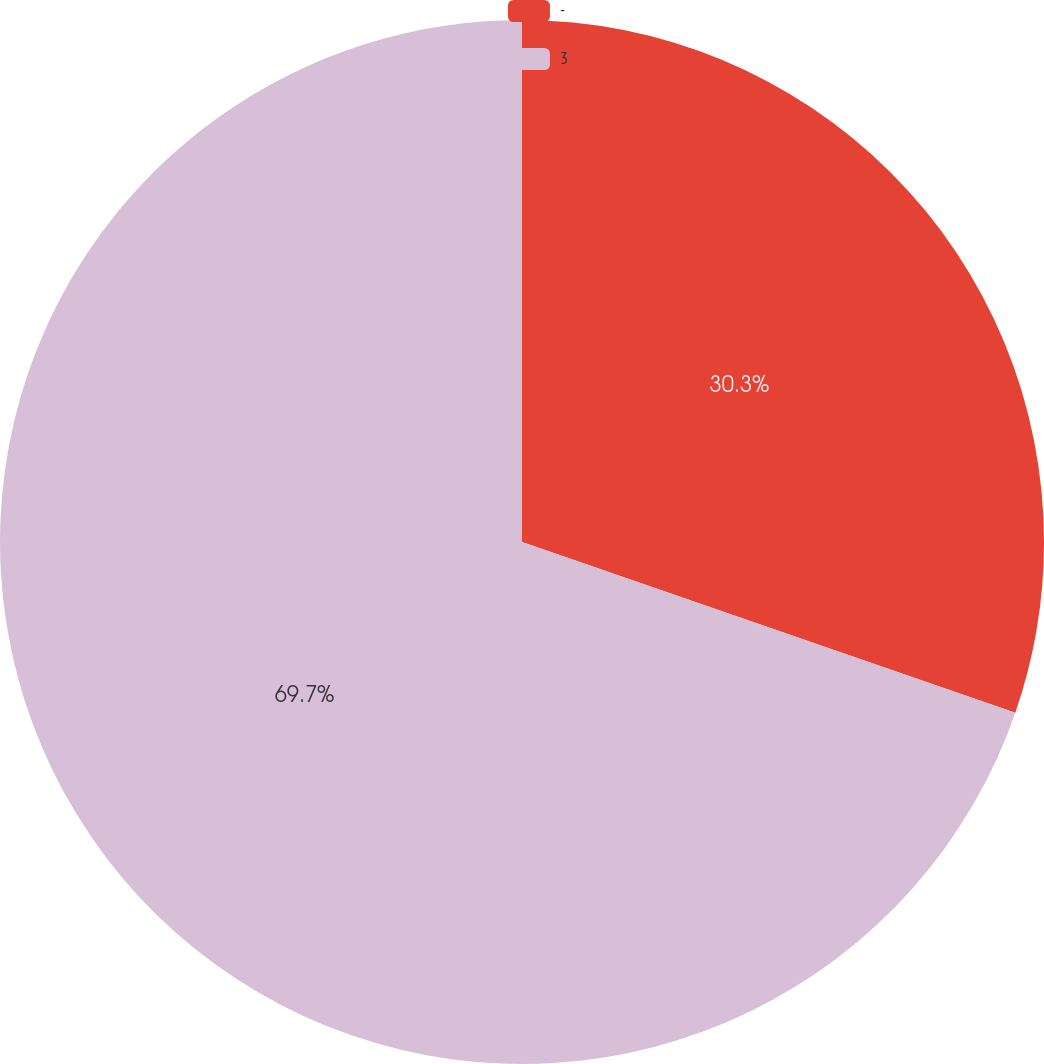<chart> <loc_0><loc_0><loc_500><loc_500><pie_chart><fcel>-<fcel>3<nl><fcel>30.3%<fcel>69.7%<nl></chart> 